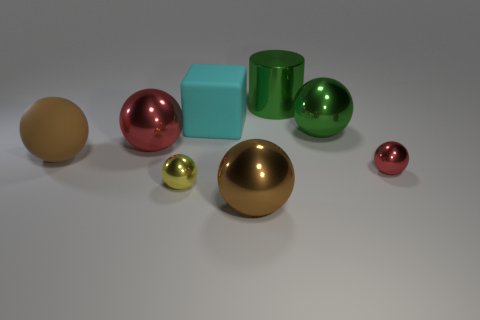Subtract all yellow balls. How many balls are left? 5 Subtract all yellow balls. How many balls are left? 5 Subtract all gray balls. Subtract all brown blocks. How many balls are left? 6 Subtract all cylinders. How many objects are left? 7 Subtract all brown balls. Subtract all small spheres. How many objects are left? 4 Add 1 rubber balls. How many rubber balls are left? 2 Add 4 big metal things. How many big metal things exist? 8 Subtract 0 blue cubes. How many objects are left? 8 